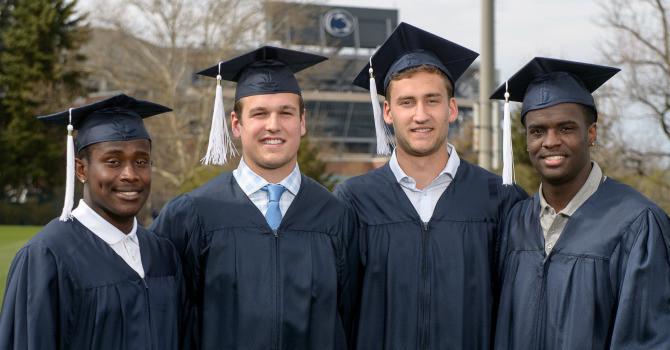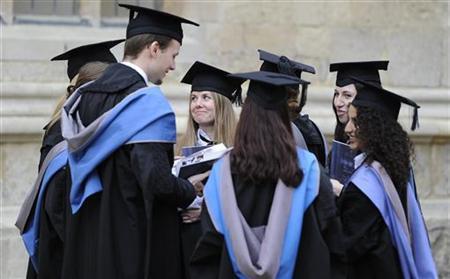The first image is the image on the left, the second image is the image on the right. For the images shown, is this caption "The people in the image on the right are standing near trees." true? Answer yes or no. No. The first image is the image on the left, the second image is the image on the right. Given the left and right images, does the statement "The left image contains only males, posed side-to-side facing forward, and at least one of them is a black man wearing a graduation cap." hold true? Answer yes or no. Yes. 